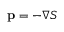<formula> <loc_0><loc_0><loc_500><loc_500>p = - \nabla S</formula> 